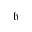Convert formula to latex. <formula><loc_0><loc_0><loc_500><loc_500>\mathfrak { h }</formula> 